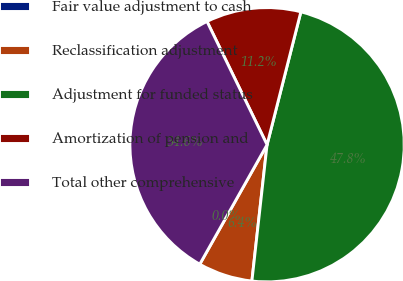Convert chart to OTSL. <chart><loc_0><loc_0><loc_500><loc_500><pie_chart><fcel>Fair value adjustment to cash<fcel>Reclassification adjustment<fcel>Adjustment for funded status<fcel>Amortization of pension and<fcel>Total other comprehensive<nl><fcel>0.0%<fcel>6.4%<fcel>47.8%<fcel>11.18%<fcel>34.62%<nl></chart> 